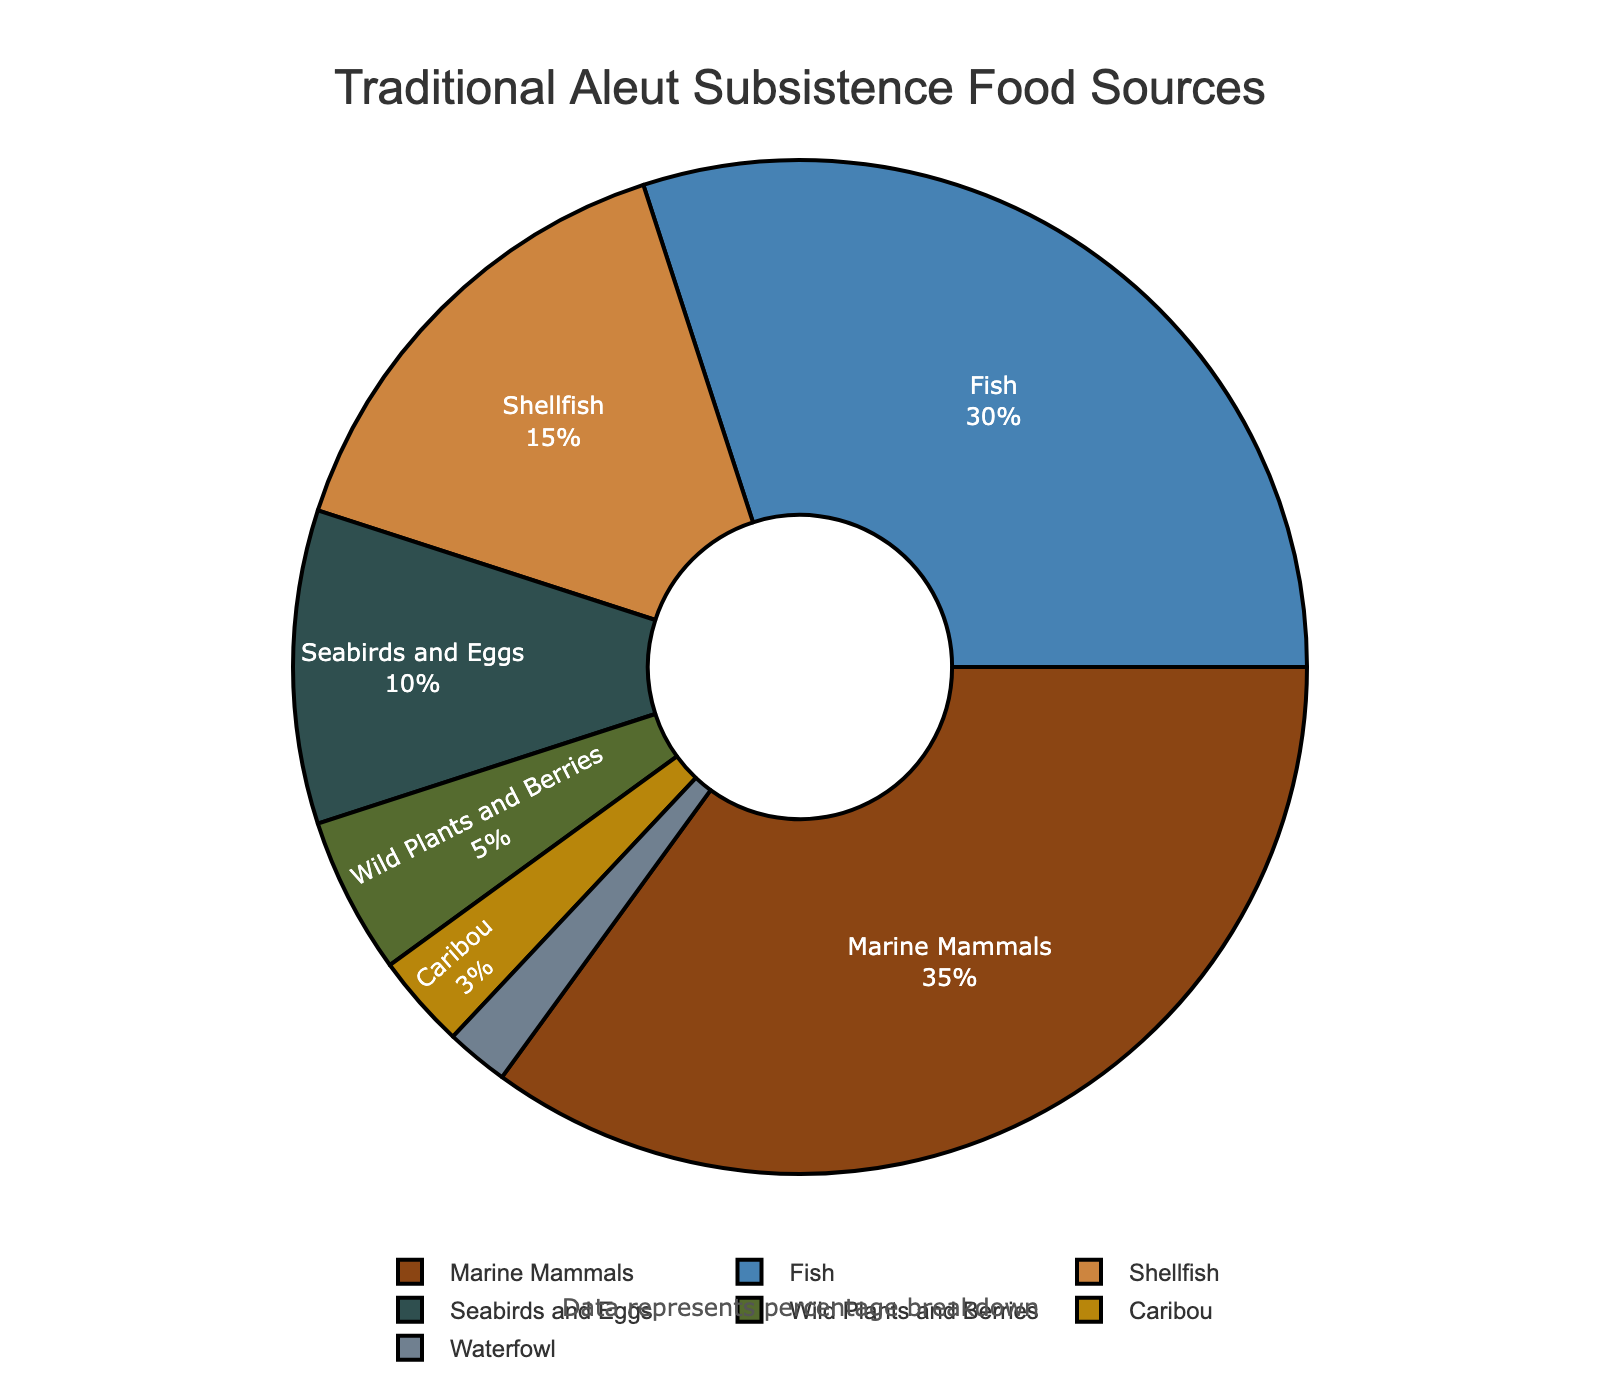Which food source has the highest percentage? The largest segment of the pie chart represents the food source with the highest percentage. Marine Mammals are the largest at 35%.
Answer: Marine Mammals What is the total percentage of food sources coming from the sea (Marine Mammals, Fish, and Shellfish)? Adding up the percentages of Marine Mammals (35%), Fish (30%), and Shellfish (15%) gives the total percentage from the sea: 35 + 30 + 15 = 80%.
Answer: 80% Which food source has the smallest contribution to the traditional Aleut diet? The smallest segment in the pie chart denotes the food source with the lowest percentage. Waterfowl is the smallest at 2%.
Answer: Waterfowl How much more percentage do Marine Mammals contribute compared to Caribou? Subtracting the percentage of Caribou (3%) from Marine Mammals (35%) gives the difference: 35 - 3 = 32%.
Answer: 32% What are the combined contributions of Seabirds and Eggs and Waterfowl? Adding the percentages of Seabirds and Eggs (10%) and Waterfowl (2%) gives their combined contribution: 10 + 2 = 12%.
Answer: 12% Compare the percentages of Fish and Shellfish. Which one is greater and by how much? Fish contribute 30% while Shellfish contribute 15%. Subtracting Shellfish's percentage from Fish's gives the difference: 30 - 15 = 15%.
Answer: Fish is greater by 15% Which category is represented by a color similar to dark brown? Marine Mammals appear in dark brown on the pie chart.
Answer: Marine Mammals How does the percentage of Wild Plants and Berries compare to that of Shellfish? Wild Plants and Berries contribute 5% whereas Shellfish contribute 15%. Shellfish contribute 10% more: 15 - 5 = 10%.
Answer: Shellfish is greater by 10% If the percentages for Fish and Shellfish were combined, what fraction of the total would they represent? Combining the percentages of Fish (30%) and Shellfish (15%) gives 45%. Since the total is 100%, the fraction they represent is 45 / 100 which is simplified to 9/20.
Answer: 9/20 What is the total contribution of land-based food sources (Caribou, Wild Plants and Berries)? Adding the percentages of Caribou (3%) and Wild Plants and Berries (5%) gives the total land-based contribution: 3 + 5 = 8%.
Answer: 8% 